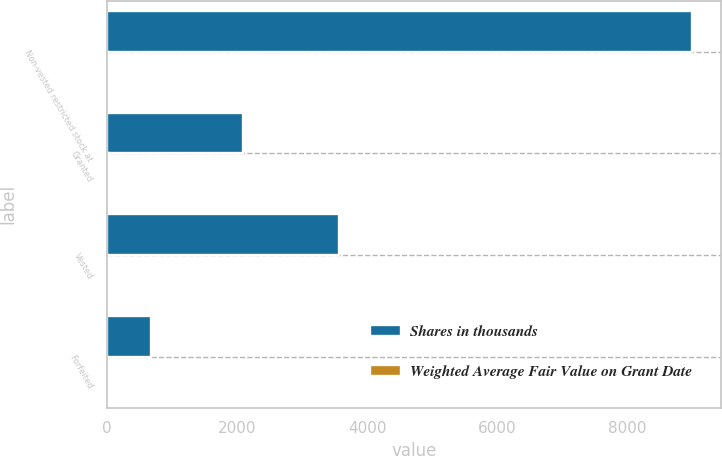<chart> <loc_0><loc_0><loc_500><loc_500><stacked_bar_chart><ecel><fcel>Non-vested restricted stock at<fcel>Granted<fcel>Vested<fcel>Forfeited<nl><fcel>Shares in thousands<fcel>8995<fcel>2090<fcel>3576<fcel>674<nl><fcel>Weighted Average Fair Value on Grant Date<fcel>17.52<fcel>26.09<fcel>14.38<fcel>11.88<nl></chart> 